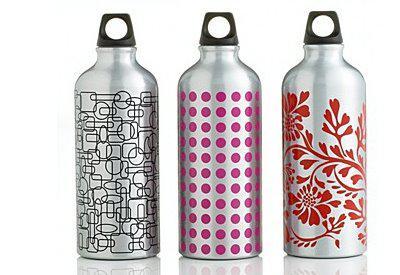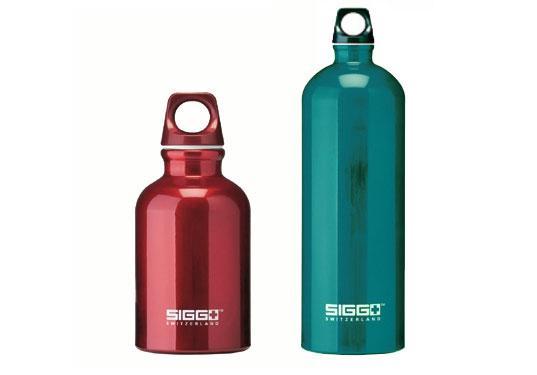The first image is the image on the left, the second image is the image on the right. Analyze the images presented: Is the assertion "There are more bottles in the left image than the right." valid? Answer yes or no. Yes. 